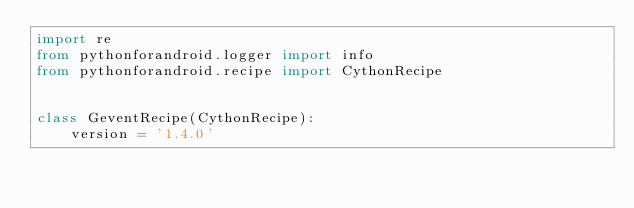Convert code to text. <code><loc_0><loc_0><loc_500><loc_500><_Python_>import re
from pythonforandroid.logger import info
from pythonforandroid.recipe import CythonRecipe


class GeventRecipe(CythonRecipe):
    version = '1.4.0'</code> 